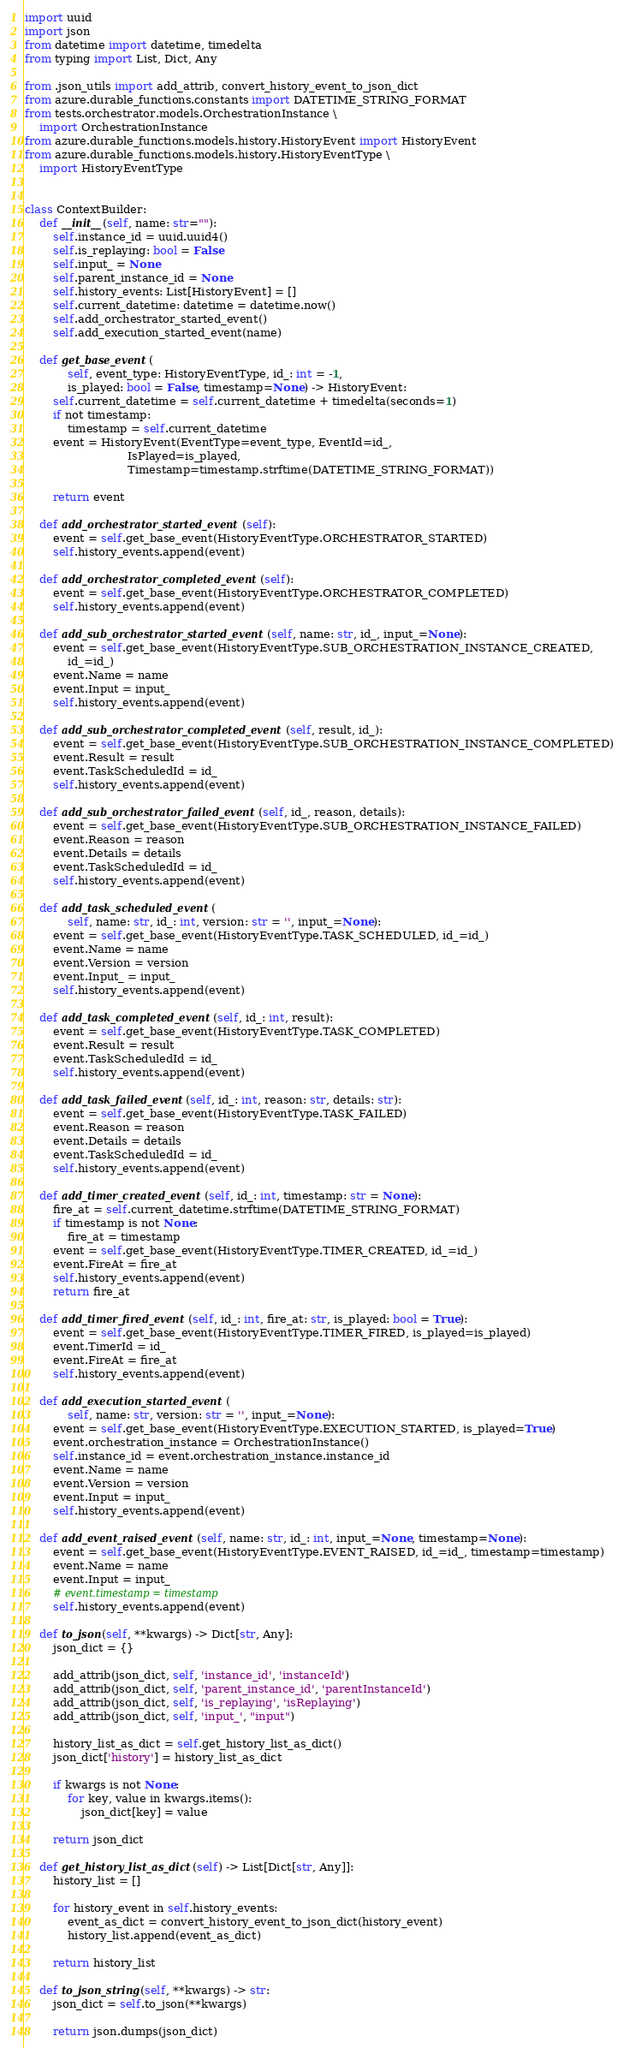<code> <loc_0><loc_0><loc_500><loc_500><_Python_>import uuid
import json
from datetime import datetime, timedelta
from typing import List, Dict, Any

from .json_utils import add_attrib, convert_history_event_to_json_dict
from azure.durable_functions.constants import DATETIME_STRING_FORMAT
from tests.orchestrator.models.OrchestrationInstance \
    import OrchestrationInstance
from azure.durable_functions.models.history.HistoryEvent import HistoryEvent
from azure.durable_functions.models.history.HistoryEventType \
    import HistoryEventType


class ContextBuilder:
    def __init__(self, name: str=""):
        self.instance_id = uuid.uuid4()
        self.is_replaying: bool = False
        self.input_ = None
        self.parent_instance_id = None
        self.history_events: List[HistoryEvent] = []
        self.current_datetime: datetime = datetime.now()
        self.add_orchestrator_started_event()
        self.add_execution_started_event(name)

    def get_base_event(
            self, event_type: HistoryEventType, id_: int = -1,
            is_played: bool = False, timestamp=None) -> HistoryEvent:
        self.current_datetime = self.current_datetime + timedelta(seconds=1)
        if not timestamp:
            timestamp = self.current_datetime
        event = HistoryEvent(EventType=event_type, EventId=id_,
                             IsPlayed=is_played,
                             Timestamp=timestamp.strftime(DATETIME_STRING_FORMAT))

        return event

    def add_orchestrator_started_event(self):
        event = self.get_base_event(HistoryEventType.ORCHESTRATOR_STARTED)
        self.history_events.append(event)

    def add_orchestrator_completed_event(self):
        event = self.get_base_event(HistoryEventType.ORCHESTRATOR_COMPLETED)
        self.history_events.append(event)

    def add_sub_orchestrator_started_event(self, name: str, id_, input_=None):
        event = self.get_base_event(HistoryEventType.SUB_ORCHESTRATION_INSTANCE_CREATED,
            id_=id_)
        event.Name = name
        event.Input = input_
        self.history_events.append(event)

    def add_sub_orchestrator_completed_event(self, result, id_):
        event = self.get_base_event(HistoryEventType.SUB_ORCHESTRATION_INSTANCE_COMPLETED)
        event.Result = result
        event.TaskScheduledId = id_
        self.history_events.append(event)

    def add_sub_orchestrator_failed_event(self, id_, reason, details):
        event = self.get_base_event(HistoryEventType.SUB_ORCHESTRATION_INSTANCE_FAILED)
        event.Reason = reason
        event.Details = details
        event.TaskScheduledId = id_
        self.history_events.append(event)

    def add_task_scheduled_event(
            self, name: str, id_: int, version: str = '', input_=None):
        event = self.get_base_event(HistoryEventType.TASK_SCHEDULED, id_=id_)
        event.Name = name
        event.Version = version
        event.Input_ = input_
        self.history_events.append(event)

    def add_task_completed_event(self, id_: int, result):
        event = self.get_base_event(HistoryEventType.TASK_COMPLETED)
        event.Result = result
        event.TaskScheduledId = id_
        self.history_events.append(event)

    def add_task_failed_event(self, id_: int, reason: str, details: str):
        event = self.get_base_event(HistoryEventType.TASK_FAILED)
        event.Reason = reason
        event.Details = details
        event.TaskScheduledId = id_
        self.history_events.append(event)

    def add_timer_created_event(self, id_: int, timestamp: str = None):
        fire_at = self.current_datetime.strftime(DATETIME_STRING_FORMAT)
        if timestamp is not None:
            fire_at = timestamp
        event = self.get_base_event(HistoryEventType.TIMER_CREATED, id_=id_)
        event.FireAt = fire_at
        self.history_events.append(event)
        return fire_at

    def add_timer_fired_event(self, id_: int, fire_at: str, is_played: bool = True):
        event = self.get_base_event(HistoryEventType.TIMER_FIRED, is_played=is_played)
        event.TimerId = id_
        event.FireAt = fire_at
        self.history_events.append(event)

    def add_execution_started_event(
            self, name: str, version: str = '', input_=None):
        event = self.get_base_event(HistoryEventType.EXECUTION_STARTED, is_played=True)
        event.orchestration_instance = OrchestrationInstance()
        self.instance_id = event.orchestration_instance.instance_id
        event.Name = name
        event.Version = version
        event.Input = input_
        self.history_events.append(event)

    def add_event_raised_event(self, name: str, id_: int, input_=None, timestamp=None):
        event = self.get_base_event(HistoryEventType.EVENT_RAISED, id_=id_, timestamp=timestamp)
        event.Name = name
        event.Input = input_
        # event.timestamp = timestamp
        self.history_events.append(event)

    def to_json(self, **kwargs) -> Dict[str, Any]:
        json_dict = {}

        add_attrib(json_dict, self, 'instance_id', 'instanceId')
        add_attrib(json_dict, self, 'parent_instance_id', 'parentInstanceId')
        add_attrib(json_dict, self, 'is_replaying', 'isReplaying')
        add_attrib(json_dict, self, 'input_', "input")

        history_list_as_dict = self.get_history_list_as_dict()
        json_dict['history'] = history_list_as_dict

        if kwargs is not None:
            for key, value in kwargs.items():
                json_dict[key] = value

        return json_dict

    def get_history_list_as_dict(self) -> List[Dict[str, Any]]:
        history_list = []

        for history_event in self.history_events:
            event_as_dict = convert_history_event_to_json_dict(history_event)
            history_list.append(event_as_dict)

        return history_list

    def to_json_string(self, **kwargs) -> str:
        json_dict = self.to_json(**kwargs)

        return json.dumps(json_dict)
</code> 